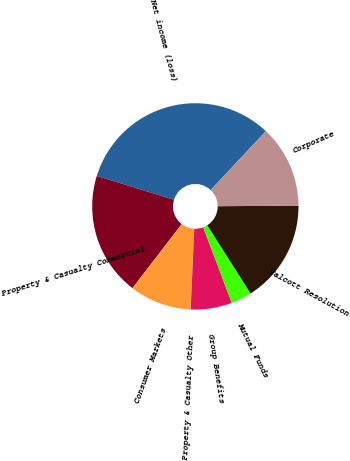Convert chart. <chart><loc_0><loc_0><loc_500><loc_500><pie_chart><fcel>Net income (loss)<fcel>Property & Casualty Commercial<fcel>Consumer Markets<fcel>Property & Casualty Other<fcel>Group Benefits<fcel>Mutual Funds<fcel>Talcott Resolution<fcel>Corporate<nl><fcel>32.21%<fcel>19.34%<fcel>9.68%<fcel>0.03%<fcel>6.47%<fcel>3.25%<fcel>16.12%<fcel>12.9%<nl></chart> 